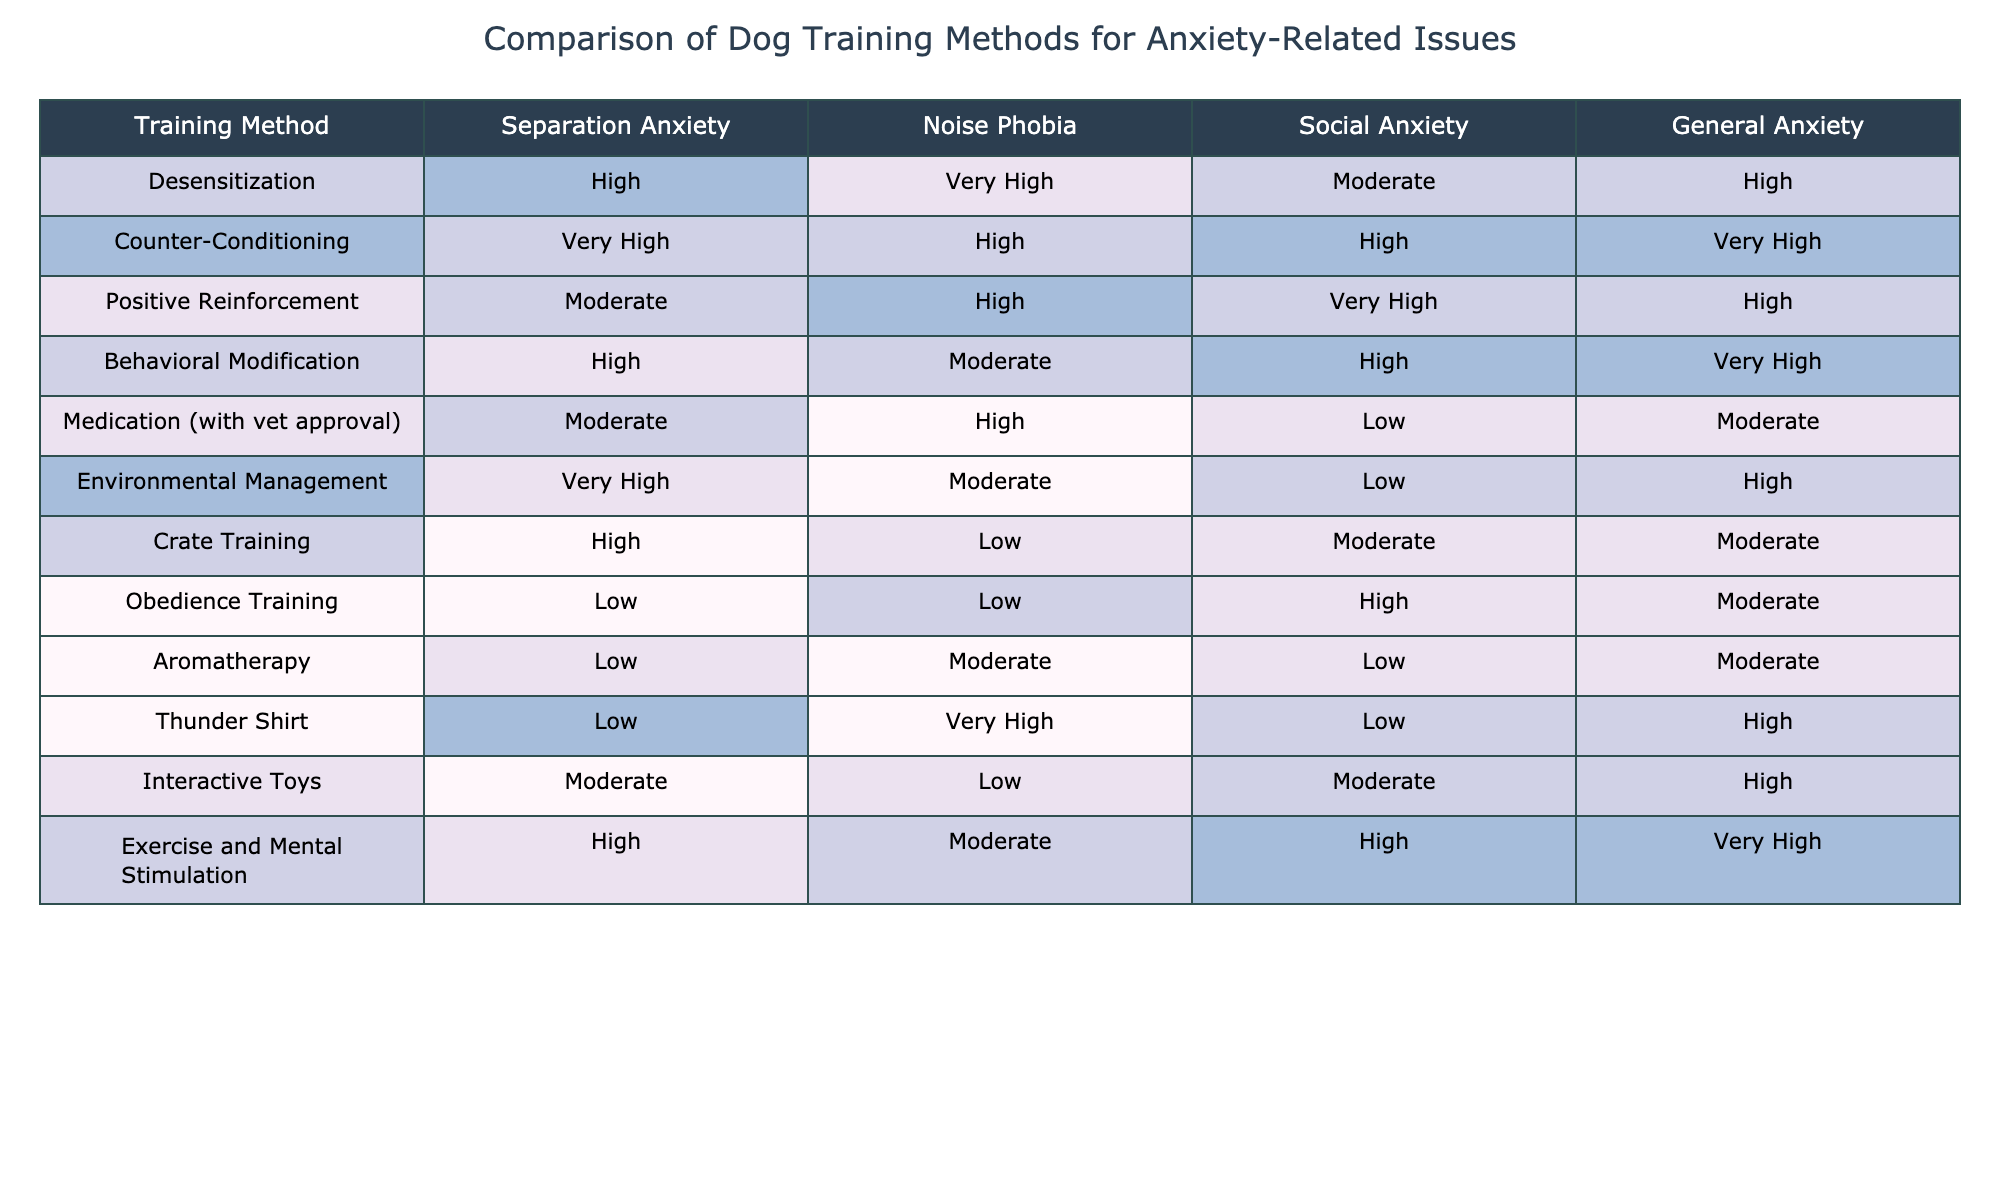What training method is rated "Very High" for Separation Anxiety? Looking at the table, the training methods are listed alongside their ratings for each anxiety-related issue. Under Separation Anxiety, the method rated "Very High" is Counter-Conditioning and Environmental Management.
Answer: Counter-Conditioning, Environmental Management Which training method is the least effective for Noise Phobia? In the Noise Phobia column, the ratings show that the lowest value is "Low," which corresponds to Crate Training and Obedience Training.
Answer: Crate Training, Obedience Training How does Positive Reinforcement rank for Social Anxiety compared to Environmental Management? For Social Anxiety, Positive Reinforcement has a rating of "Very High" while Environmental Management has a rating of "Low." "Very High" is definitely higher than "Low."
Answer: Positive Reinforcement is ranked higher What is the average effectiveness rating for Exercise and Mental Stimulation across all anxiety issues? The ratings for Exercise and Mental Stimulation are High (3) for Separation Anxiety, Moderate (2) for Noise Phobia, High (3) for Social Anxiety, and Very High (4) for General Anxiety. Calculating the average: (3 + 2 + 3 + 4) / 4 = 3.
Answer: 3 Is there any training method that has a Low rating for all types of anxiety-related issues? By analyzing each row in the table for instances of "Low," it can be seen that the only rating that consistently appears as Low is with Aromatherapy, but it does not have all Low ratings. Therefore, there is no training method rated Low across all issues.
Answer: No Which method has the highest rating for General Anxiety? For General Anxiety, the highest rating in the table is "Very High," which corresponds to Counter-Conditioning and Exercise and Mental Stimulation.
Answer: Counter-Conditioning, Exercise and Mental Stimulation What training method shows a significant difference in ratings between Separation Anxiety and Noise Phobia? Comparing the ratings for Separation Anxiety and Noise Phobia reveals a significant difference for methods like Thunder Shirt which is rated Low in Separation Anxiety (0) and Very High in Noise Phobia (4).
Answer: Thunder Shirt Which training methods have a Moderate rating for at least two anxiety issues? Examination of the table shows that Positive Reinforcement (Social Anxiety, Noise Phobia) and Medication with vet approval (General Anxiety, Social Anxiety) both have Moderate ratings for at least two anxiety issues.
Answer: Positive Reinforcement, Medication (with vet approval) Which training method is the most versatile based on its ratings across all anxiety types? To determine versatility, we look at the spread of ratings across all anxiety types. Counter-Conditioning has ratings of Very High, High, High, and Very High, demonstrating effectiveness across different issues.
Answer: Counter-Conditioning 